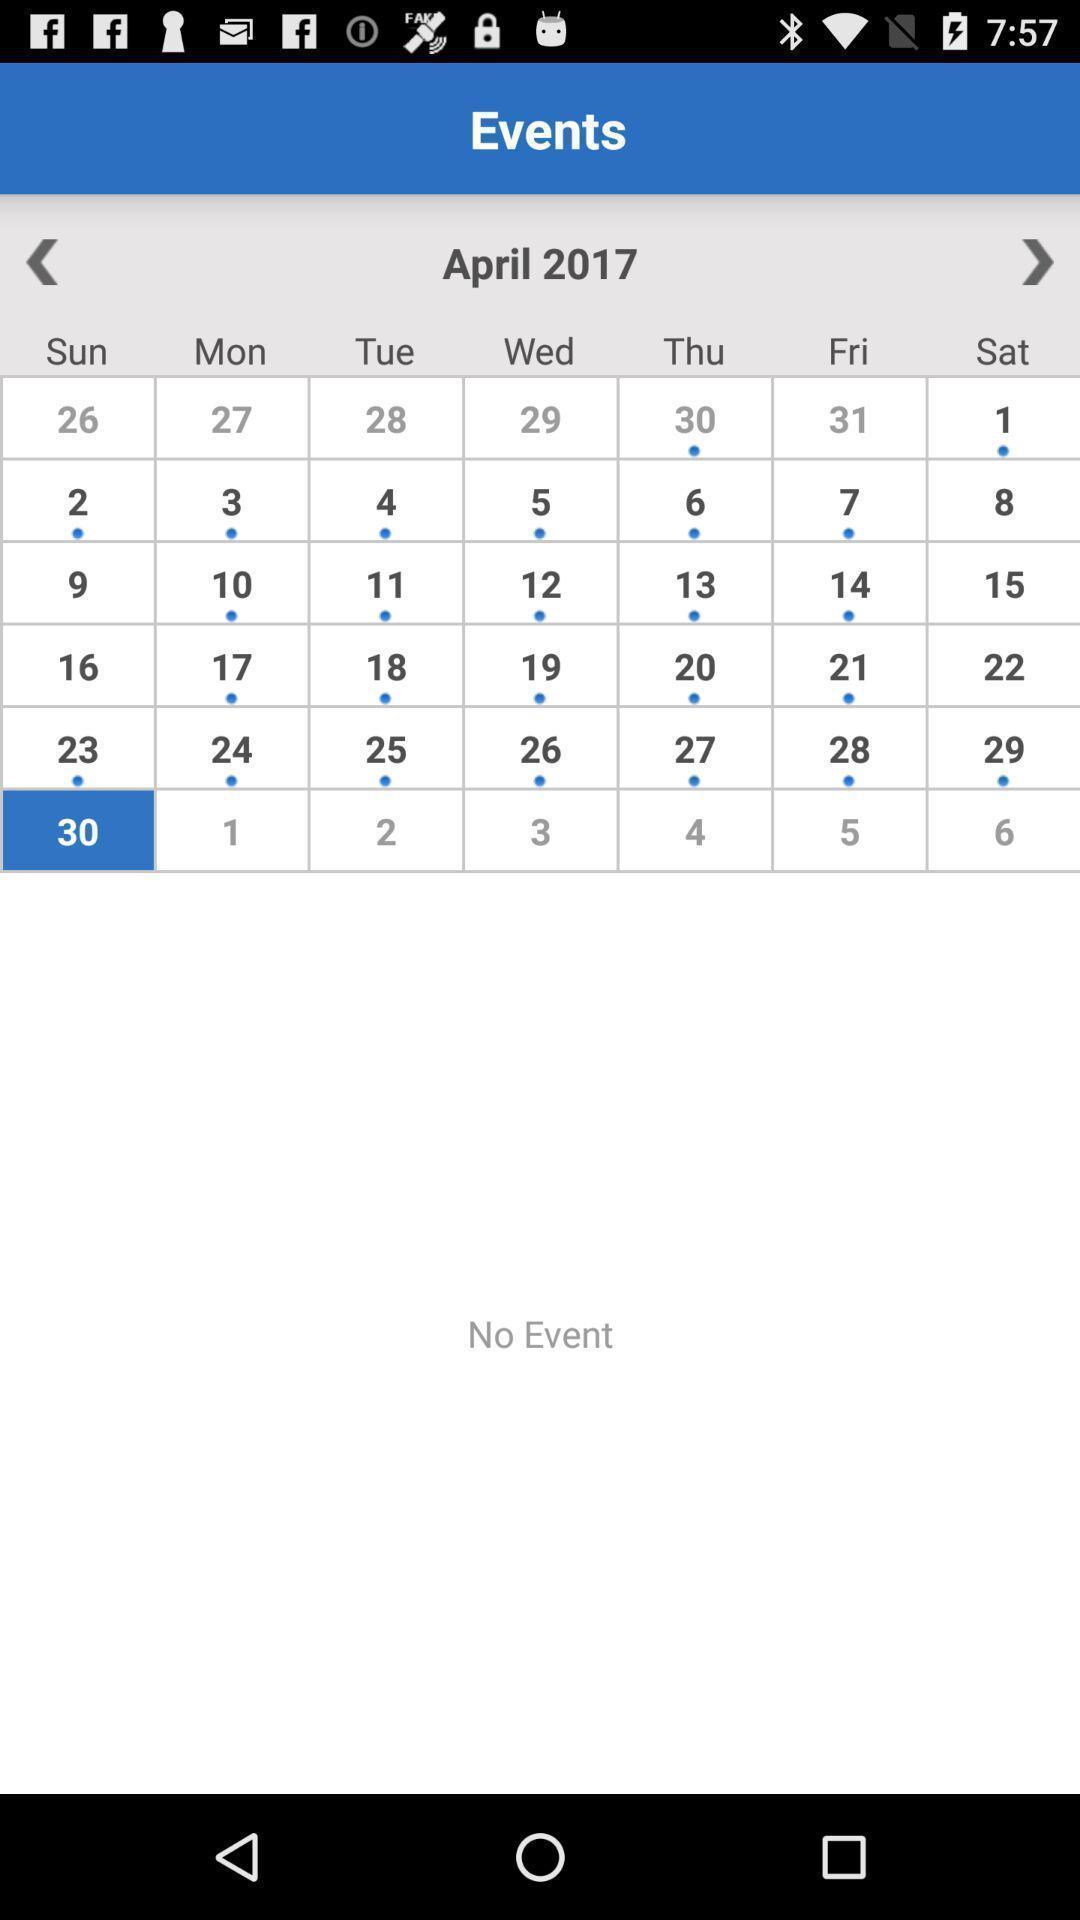Please provide a description for this image. Screen shows events with a calendar. 